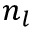<formula> <loc_0><loc_0><loc_500><loc_500>n _ { l }</formula> 